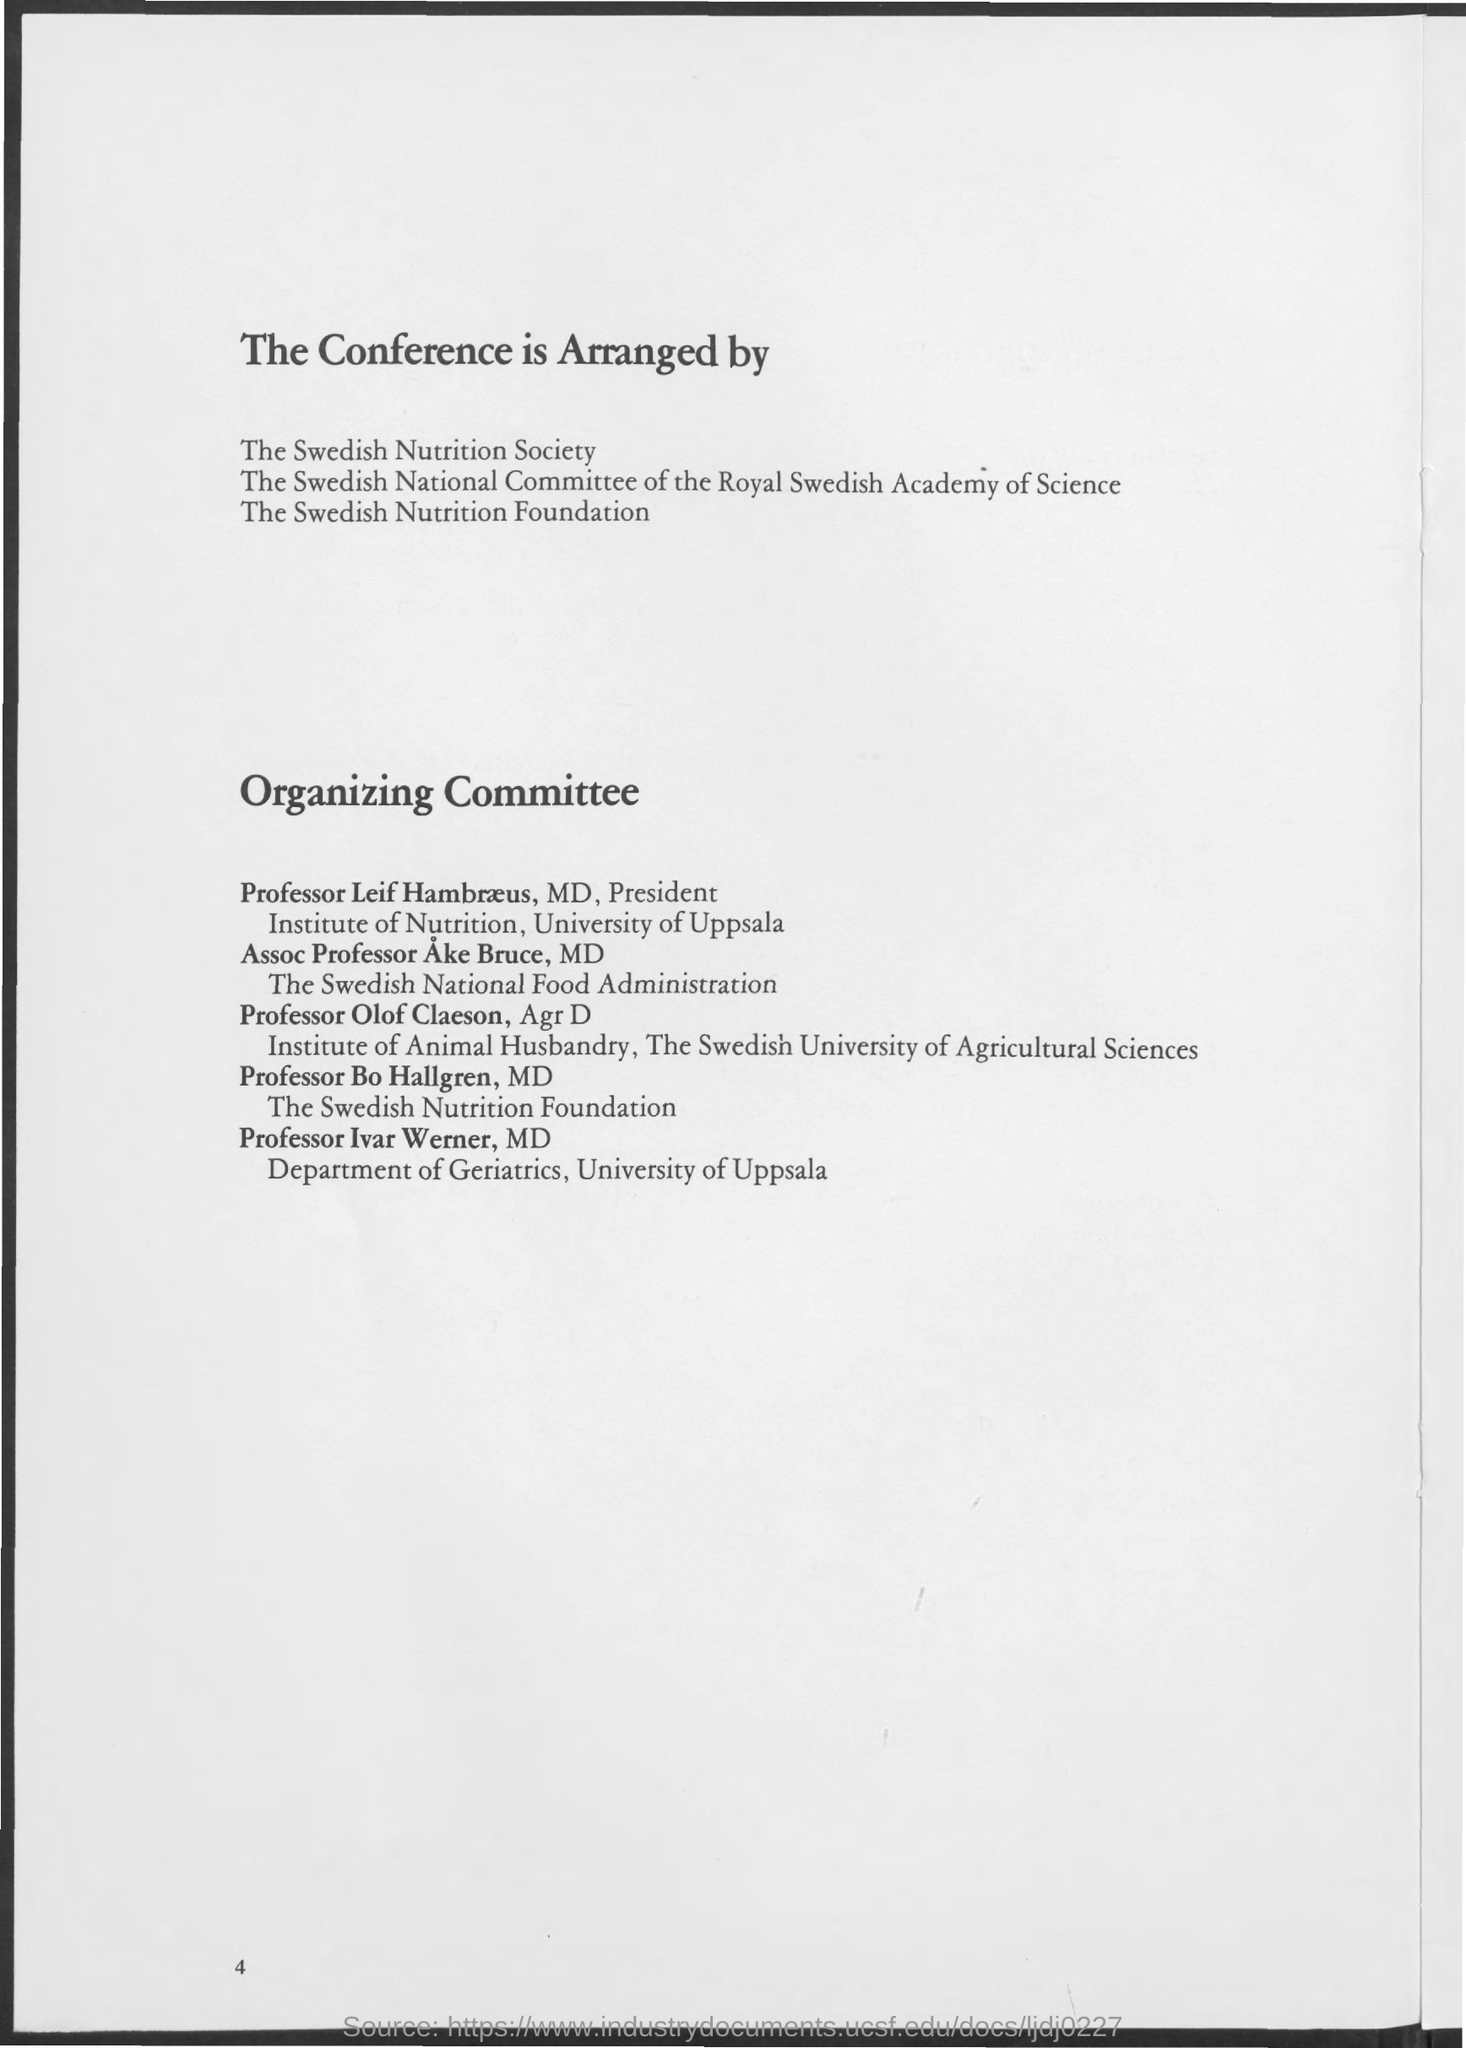List a handful of essential elements in this visual. On the bottom of page 4, the page number is located. The Swedish National Food Administration is represented by Assoc Professor Ake Bruce, MD. The Department of Geriatrics at the University of Uppsala is represented by Professor Ivar Werner. 